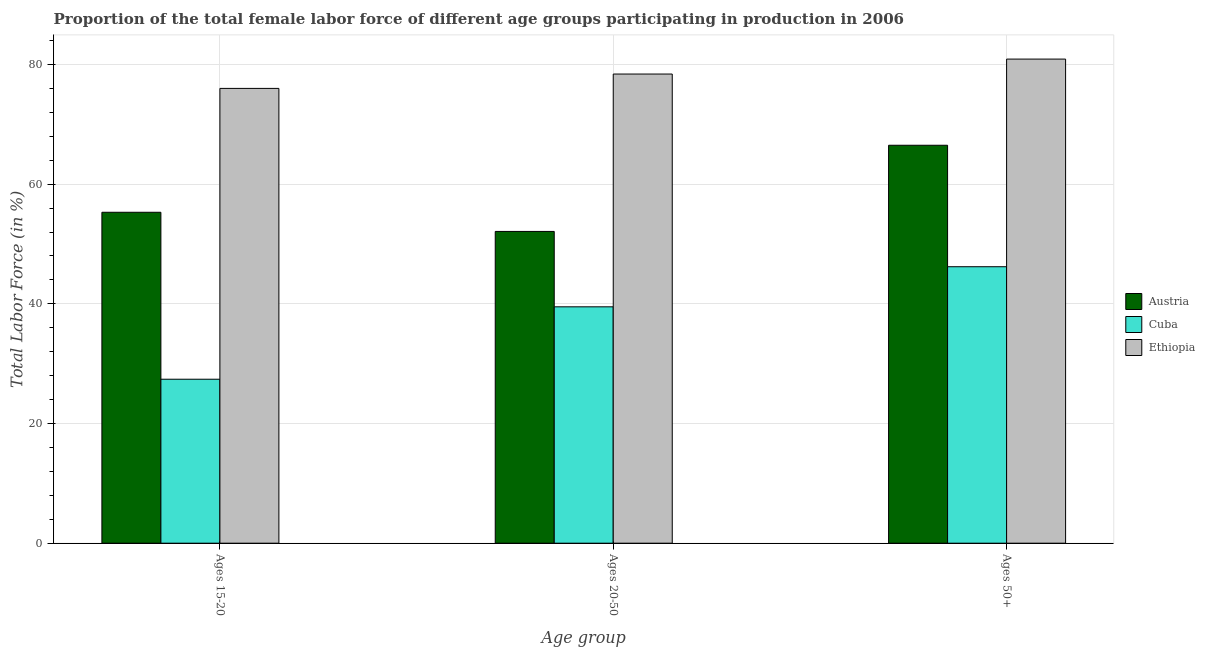How many different coloured bars are there?
Give a very brief answer. 3. How many groups of bars are there?
Provide a short and direct response. 3. How many bars are there on the 3rd tick from the left?
Offer a terse response. 3. What is the label of the 2nd group of bars from the left?
Your answer should be very brief. Ages 20-50. What is the percentage of female labor force within the age group 15-20 in Ethiopia?
Provide a short and direct response. 76. Across all countries, what is the maximum percentage of female labor force within the age group 20-50?
Your response must be concise. 78.4. Across all countries, what is the minimum percentage of female labor force above age 50?
Provide a succinct answer. 46.2. In which country was the percentage of female labor force above age 50 maximum?
Ensure brevity in your answer.  Ethiopia. In which country was the percentage of female labor force within the age group 15-20 minimum?
Offer a terse response. Cuba. What is the total percentage of female labor force within the age group 20-50 in the graph?
Make the answer very short. 170. What is the difference between the percentage of female labor force within the age group 20-50 in Cuba and that in Ethiopia?
Offer a terse response. -38.9. What is the difference between the percentage of female labor force within the age group 15-20 in Austria and the percentage of female labor force within the age group 20-50 in Cuba?
Provide a short and direct response. 15.8. What is the average percentage of female labor force within the age group 20-50 per country?
Give a very brief answer. 56.67. What is the difference between the percentage of female labor force within the age group 15-20 and percentage of female labor force within the age group 20-50 in Cuba?
Your answer should be compact. -12.1. In how many countries, is the percentage of female labor force within the age group 15-20 greater than 56 %?
Make the answer very short. 1. What is the ratio of the percentage of female labor force above age 50 in Austria to that in Cuba?
Provide a succinct answer. 1.44. What is the difference between the highest and the second highest percentage of female labor force within the age group 20-50?
Give a very brief answer. 26.3. What is the difference between the highest and the lowest percentage of female labor force above age 50?
Your answer should be very brief. 34.7. In how many countries, is the percentage of female labor force above age 50 greater than the average percentage of female labor force above age 50 taken over all countries?
Offer a very short reply. 2. What does the 2nd bar from the left in Ages 15-20 represents?
Provide a short and direct response. Cuba. What does the 3rd bar from the right in Ages 50+ represents?
Offer a very short reply. Austria. Is it the case that in every country, the sum of the percentage of female labor force within the age group 15-20 and percentage of female labor force within the age group 20-50 is greater than the percentage of female labor force above age 50?
Your answer should be very brief. Yes. Are all the bars in the graph horizontal?
Your response must be concise. No. Where does the legend appear in the graph?
Provide a succinct answer. Center right. What is the title of the graph?
Offer a terse response. Proportion of the total female labor force of different age groups participating in production in 2006. Does "Solomon Islands" appear as one of the legend labels in the graph?
Make the answer very short. No. What is the label or title of the X-axis?
Ensure brevity in your answer.  Age group. What is the label or title of the Y-axis?
Offer a terse response. Total Labor Force (in %). What is the Total Labor Force (in %) of Austria in Ages 15-20?
Ensure brevity in your answer.  55.3. What is the Total Labor Force (in %) of Cuba in Ages 15-20?
Provide a short and direct response. 27.4. What is the Total Labor Force (in %) in Ethiopia in Ages 15-20?
Keep it short and to the point. 76. What is the Total Labor Force (in %) in Austria in Ages 20-50?
Give a very brief answer. 52.1. What is the Total Labor Force (in %) of Cuba in Ages 20-50?
Keep it short and to the point. 39.5. What is the Total Labor Force (in %) of Ethiopia in Ages 20-50?
Provide a short and direct response. 78.4. What is the Total Labor Force (in %) in Austria in Ages 50+?
Offer a very short reply. 66.5. What is the Total Labor Force (in %) in Cuba in Ages 50+?
Offer a terse response. 46.2. What is the Total Labor Force (in %) of Ethiopia in Ages 50+?
Your response must be concise. 80.9. Across all Age group, what is the maximum Total Labor Force (in %) in Austria?
Provide a succinct answer. 66.5. Across all Age group, what is the maximum Total Labor Force (in %) in Cuba?
Give a very brief answer. 46.2. Across all Age group, what is the maximum Total Labor Force (in %) of Ethiopia?
Offer a very short reply. 80.9. Across all Age group, what is the minimum Total Labor Force (in %) in Austria?
Your answer should be compact. 52.1. Across all Age group, what is the minimum Total Labor Force (in %) in Cuba?
Give a very brief answer. 27.4. What is the total Total Labor Force (in %) of Austria in the graph?
Provide a succinct answer. 173.9. What is the total Total Labor Force (in %) of Cuba in the graph?
Offer a terse response. 113.1. What is the total Total Labor Force (in %) of Ethiopia in the graph?
Your answer should be compact. 235.3. What is the difference between the Total Labor Force (in %) of Cuba in Ages 15-20 and that in Ages 20-50?
Your answer should be compact. -12.1. What is the difference between the Total Labor Force (in %) of Austria in Ages 15-20 and that in Ages 50+?
Your response must be concise. -11.2. What is the difference between the Total Labor Force (in %) of Cuba in Ages 15-20 and that in Ages 50+?
Make the answer very short. -18.8. What is the difference between the Total Labor Force (in %) of Austria in Ages 20-50 and that in Ages 50+?
Provide a succinct answer. -14.4. What is the difference between the Total Labor Force (in %) in Austria in Ages 15-20 and the Total Labor Force (in %) in Ethiopia in Ages 20-50?
Your response must be concise. -23.1. What is the difference between the Total Labor Force (in %) of Cuba in Ages 15-20 and the Total Labor Force (in %) of Ethiopia in Ages 20-50?
Ensure brevity in your answer.  -51. What is the difference between the Total Labor Force (in %) in Austria in Ages 15-20 and the Total Labor Force (in %) in Cuba in Ages 50+?
Keep it short and to the point. 9.1. What is the difference between the Total Labor Force (in %) of Austria in Ages 15-20 and the Total Labor Force (in %) of Ethiopia in Ages 50+?
Your answer should be compact. -25.6. What is the difference between the Total Labor Force (in %) in Cuba in Ages 15-20 and the Total Labor Force (in %) in Ethiopia in Ages 50+?
Ensure brevity in your answer.  -53.5. What is the difference between the Total Labor Force (in %) in Austria in Ages 20-50 and the Total Labor Force (in %) in Cuba in Ages 50+?
Your answer should be compact. 5.9. What is the difference between the Total Labor Force (in %) of Austria in Ages 20-50 and the Total Labor Force (in %) of Ethiopia in Ages 50+?
Offer a terse response. -28.8. What is the difference between the Total Labor Force (in %) of Cuba in Ages 20-50 and the Total Labor Force (in %) of Ethiopia in Ages 50+?
Your answer should be very brief. -41.4. What is the average Total Labor Force (in %) in Austria per Age group?
Offer a very short reply. 57.97. What is the average Total Labor Force (in %) of Cuba per Age group?
Ensure brevity in your answer.  37.7. What is the average Total Labor Force (in %) of Ethiopia per Age group?
Offer a very short reply. 78.43. What is the difference between the Total Labor Force (in %) in Austria and Total Labor Force (in %) in Cuba in Ages 15-20?
Offer a terse response. 27.9. What is the difference between the Total Labor Force (in %) of Austria and Total Labor Force (in %) of Ethiopia in Ages 15-20?
Give a very brief answer. -20.7. What is the difference between the Total Labor Force (in %) in Cuba and Total Labor Force (in %) in Ethiopia in Ages 15-20?
Your answer should be compact. -48.6. What is the difference between the Total Labor Force (in %) of Austria and Total Labor Force (in %) of Ethiopia in Ages 20-50?
Offer a terse response. -26.3. What is the difference between the Total Labor Force (in %) of Cuba and Total Labor Force (in %) of Ethiopia in Ages 20-50?
Your answer should be very brief. -38.9. What is the difference between the Total Labor Force (in %) of Austria and Total Labor Force (in %) of Cuba in Ages 50+?
Provide a short and direct response. 20.3. What is the difference between the Total Labor Force (in %) in Austria and Total Labor Force (in %) in Ethiopia in Ages 50+?
Offer a terse response. -14.4. What is the difference between the Total Labor Force (in %) in Cuba and Total Labor Force (in %) in Ethiopia in Ages 50+?
Offer a terse response. -34.7. What is the ratio of the Total Labor Force (in %) in Austria in Ages 15-20 to that in Ages 20-50?
Provide a short and direct response. 1.06. What is the ratio of the Total Labor Force (in %) of Cuba in Ages 15-20 to that in Ages 20-50?
Provide a succinct answer. 0.69. What is the ratio of the Total Labor Force (in %) in Ethiopia in Ages 15-20 to that in Ages 20-50?
Your response must be concise. 0.97. What is the ratio of the Total Labor Force (in %) in Austria in Ages 15-20 to that in Ages 50+?
Provide a succinct answer. 0.83. What is the ratio of the Total Labor Force (in %) of Cuba in Ages 15-20 to that in Ages 50+?
Ensure brevity in your answer.  0.59. What is the ratio of the Total Labor Force (in %) in Ethiopia in Ages 15-20 to that in Ages 50+?
Provide a short and direct response. 0.94. What is the ratio of the Total Labor Force (in %) of Austria in Ages 20-50 to that in Ages 50+?
Offer a terse response. 0.78. What is the ratio of the Total Labor Force (in %) of Cuba in Ages 20-50 to that in Ages 50+?
Ensure brevity in your answer.  0.85. What is the ratio of the Total Labor Force (in %) of Ethiopia in Ages 20-50 to that in Ages 50+?
Offer a very short reply. 0.97. What is the difference between the highest and the second highest Total Labor Force (in %) of Austria?
Provide a short and direct response. 11.2. What is the difference between the highest and the second highest Total Labor Force (in %) of Ethiopia?
Ensure brevity in your answer.  2.5. What is the difference between the highest and the lowest Total Labor Force (in %) in Austria?
Make the answer very short. 14.4. 